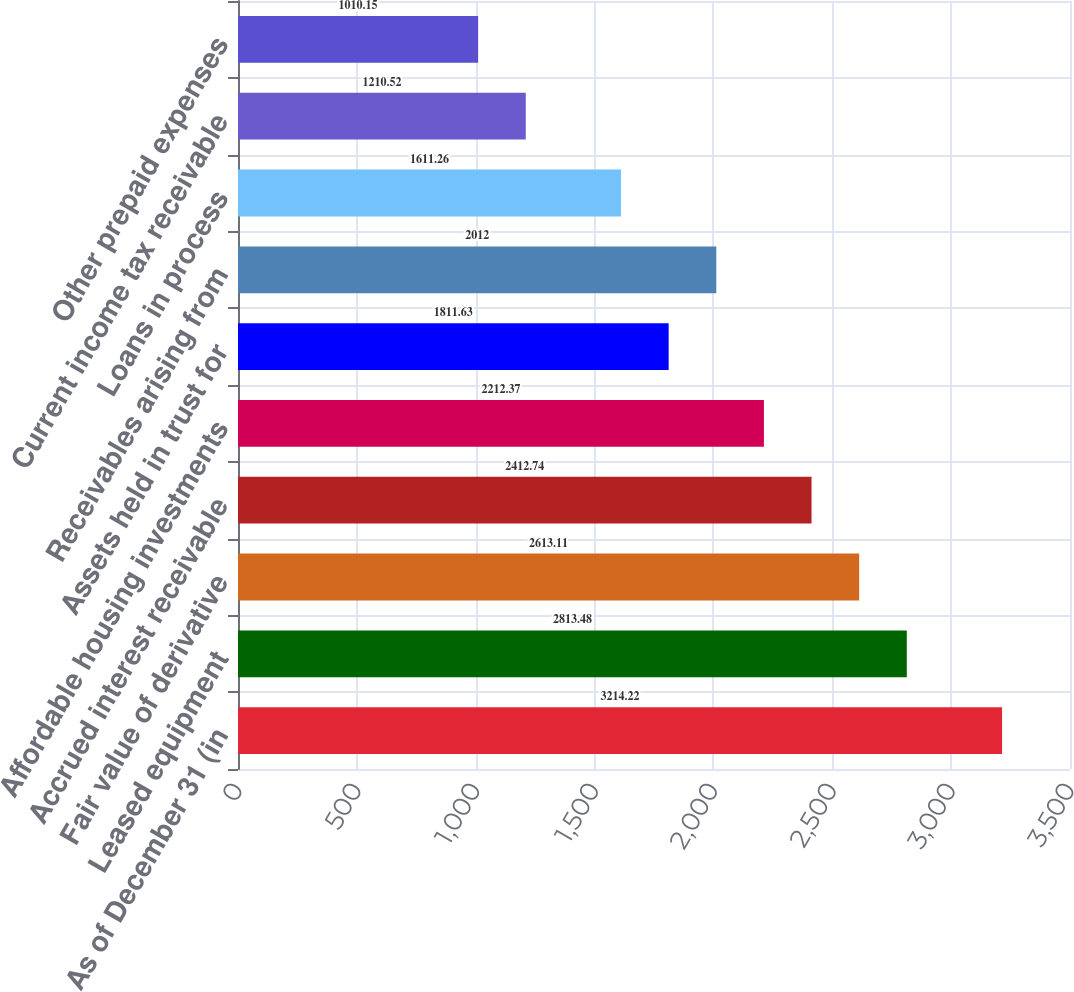Convert chart. <chart><loc_0><loc_0><loc_500><loc_500><bar_chart><fcel>As of December 31 (in<fcel>Leased equipment<fcel>Fair value of derivative<fcel>Accrued interest receivable<fcel>Affordable housing investments<fcel>Assets held in trust for<fcel>Receivables arising from<fcel>Loans in process<fcel>Current income tax receivable<fcel>Other prepaid expenses<nl><fcel>3214.22<fcel>2813.48<fcel>2613.11<fcel>2412.74<fcel>2212.37<fcel>1811.63<fcel>2012<fcel>1611.26<fcel>1210.52<fcel>1010.15<nl></chart> 